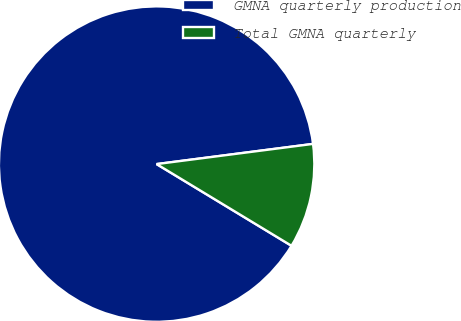<chart> <loc_0><loc_0><loc_500><loc_500><pie_chart><fcel>GMNA quarterly production<fcel>Total GMNA quarterly<nl><fcel>89.29%<fcel>10.71%<nl></chart> 